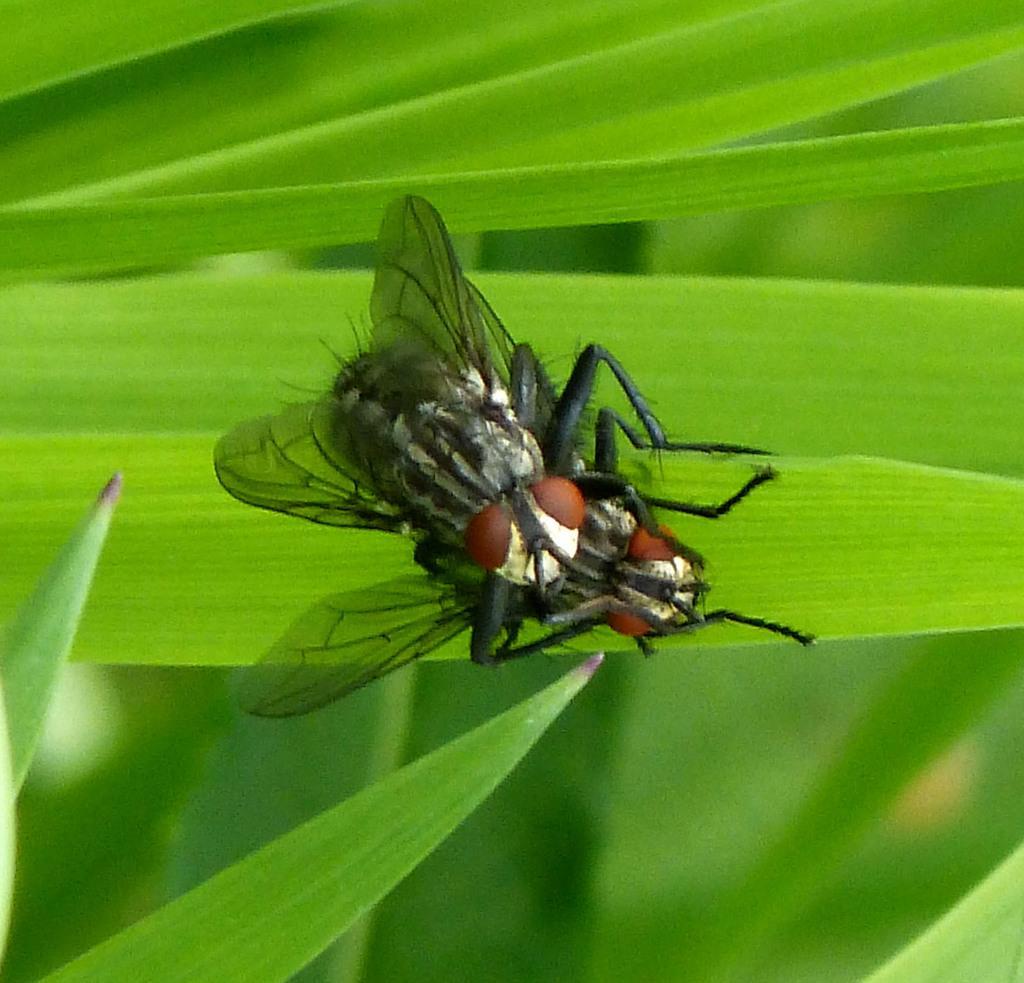Could you give a brief overview of what you see in this image? In this picture, we see the two house flies are on the green color leaves. In the background, it is green in color and this picture is blurred in the background. 